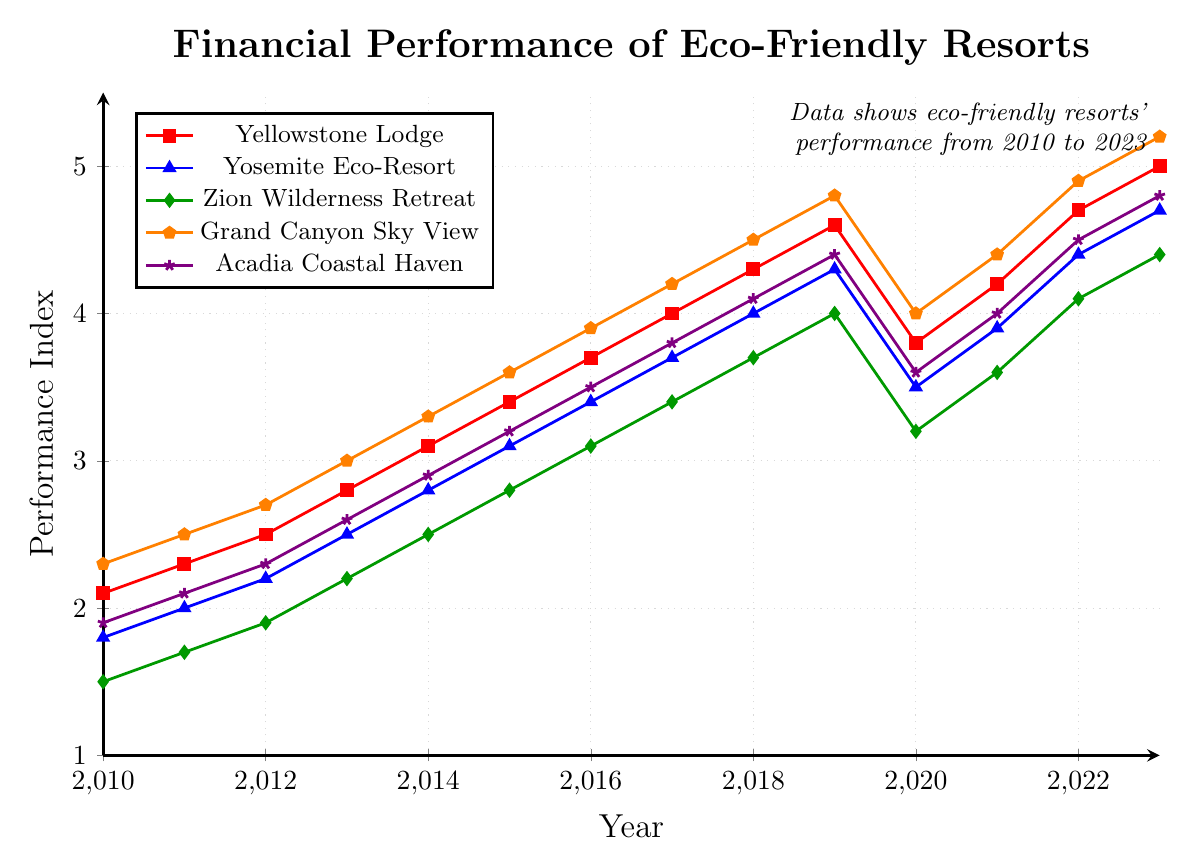Which eco-friendly resort had the best financial performance in 2023? By looking at the year 2023 in the figure, we can see that the eco-friendly resort with the highest performance index is 'Grand Canyon Sky View' with a value of 5.2
Answer: Grand Canyon Sky View How did the financial performance of Yellowstone Lodge change from 2020 to 2021? Consulting the figure, the financial performance index for Yellowstone Lodge in 2020 was 3.8, and it increased to 4.2 in 2021. Therefore, the change is 4.2 - 3.8 = 0.4
Answer: Increased by 0.4 Which resort showed the greatest financial performance improvement from 2010 to 2023? Observing the initial and final points for each resort from 2010 to 2023: 
- Yellowstone Lodge: 5.0 - 2.1 = 2.9
- Yosemite Eco-Resort: 4.7 - 1.8 = 2.9
- Zion Wilderness Retreat: 4.4 - 1.5 = 2.9
- Grand Canyon Sky View: 5.2 - 2.3 = 2.9
- Acadia Coastal Haven: 4.8 - 1.9 = 2.9
All resorts improved equally by 2.9
Answer: All resorts equally In which year did Acadia Coastal Haven first surpass a financial performance index of 4.0? Reviewing the plotted values for Acadia Coastal Haven, the index first surpasses 4.0 in the year 2018
Answer: 2018 What was the financial performance index for Zion Wilderness Retreat in 2020, and how does it compare to its performance in 2019? For Zion Wilderness Retreat, the index in 2020 was 3.2, while in 2019 it was 4.0. The decrease is calculated as 4.0 - 3.2 = 0.8
Answer: Decreased by 0.8 Which resort had the steadiest growth over the given period? Evaluating the smoothness and steadiness of the curves for each resort in the figure, 'Yellowstone Lodge' has a steady upward trend with consistent increments over the years without sharp declines
Answer: Yellowstone Lodge What is the average financial performance index of all the resorts in 2021? Averaging the values for all resorts in 2021:
- Yellowstone Lodge: 4.2
- Yosemite Eco-Resort: 3.9
- Zion Wilderness Retreat: 3.6
- Grand Canyon Sky View: 4.4
- Acadia Coastal Haven: 4.0
Sum: 4.2 + 3.9 + 3.6 + 4.4 + 4.0 = 20.1
Average: 20.1/5 = 4.02
Answer: 4.02 Can you identify the resort that was least affected by the decrease in the financial performance index in 2020? From the graph, Yellowstone Lodge had a decrease from 4.6 in 2019 to 3.8 in 2020, which is a drop of 0.8, similarly:
- Yosemite Eco-Resort: 4.3 to 3.5 = 0.8
- Zion Wilderness Retreat: 4.0 to 3.2 = 0.8
- Grand Canyon Sky View: 4.8 to 4.0 = 0.8
- Acadia Coastal Haven: 4.4 to 3.6 = 0.8
All resorts were equally affected by the decrease in performance
Answer: All resorts equally Which year saw the sharpest increase in financial performance for Yosemite Eco-Resort? The steepest increase for Yosemite Eco-Resort can be observed between the years 2021 and 2022, where the index increased from 3.9 to 4.4, a growth of 0.5
Answer: 2022 